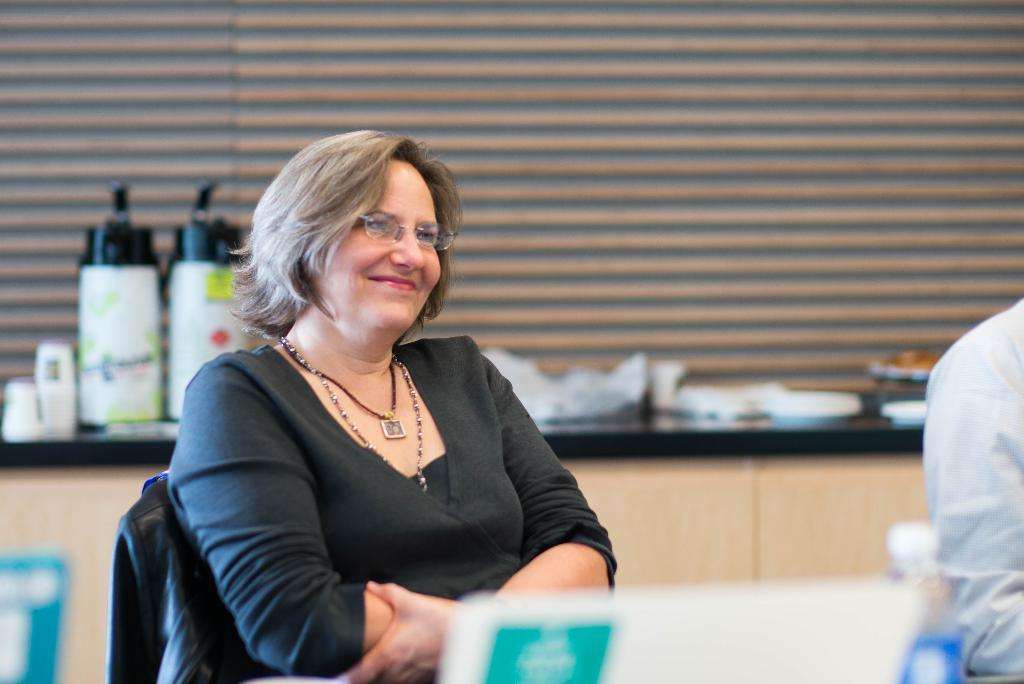Who is present in the image? There is a woman in the image. What is the woman wearing? The woman is wearing a black dress. What is the woman doing in the image? The woman is sitting in a chair. Who is sitting beside the woman? There is another person sitting beside the woman. What can be seen in the background of the image? There are other objects in the background of the image. What type of wool is the woman using to cover her face in the image? There is no wool present in the image, and the woman is not covering her face. 